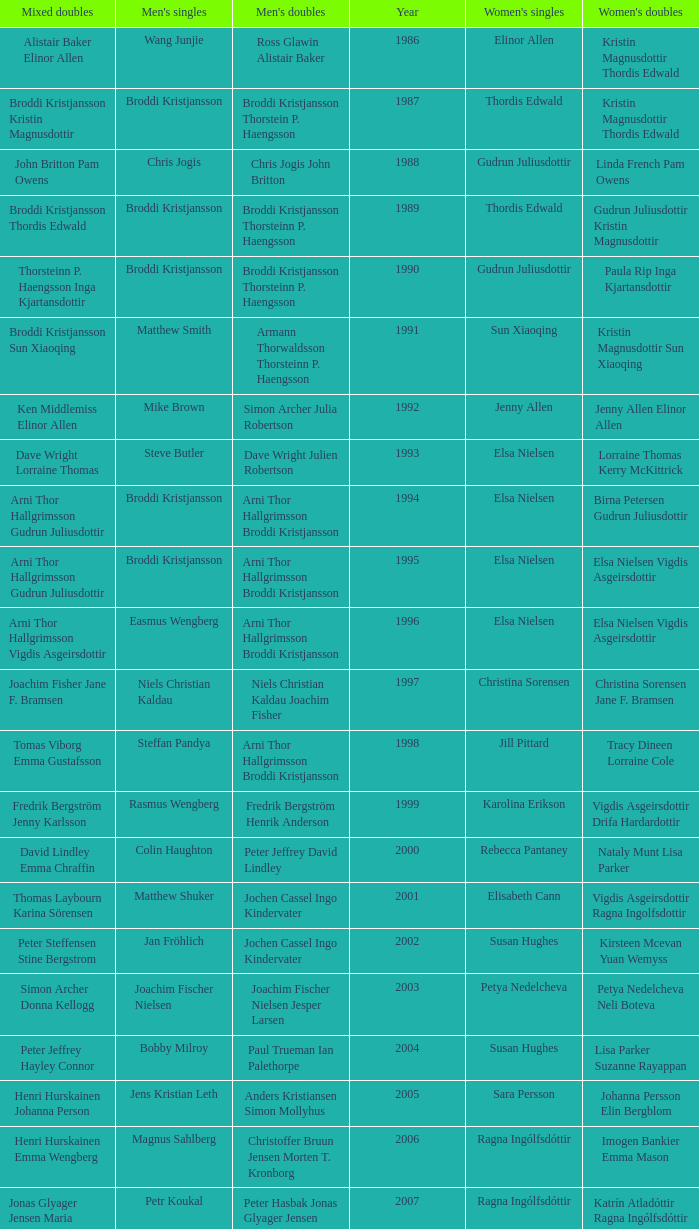Which mixed doubles happened later than 2011? Chou Tien-chen Chiang Mei-hui. 